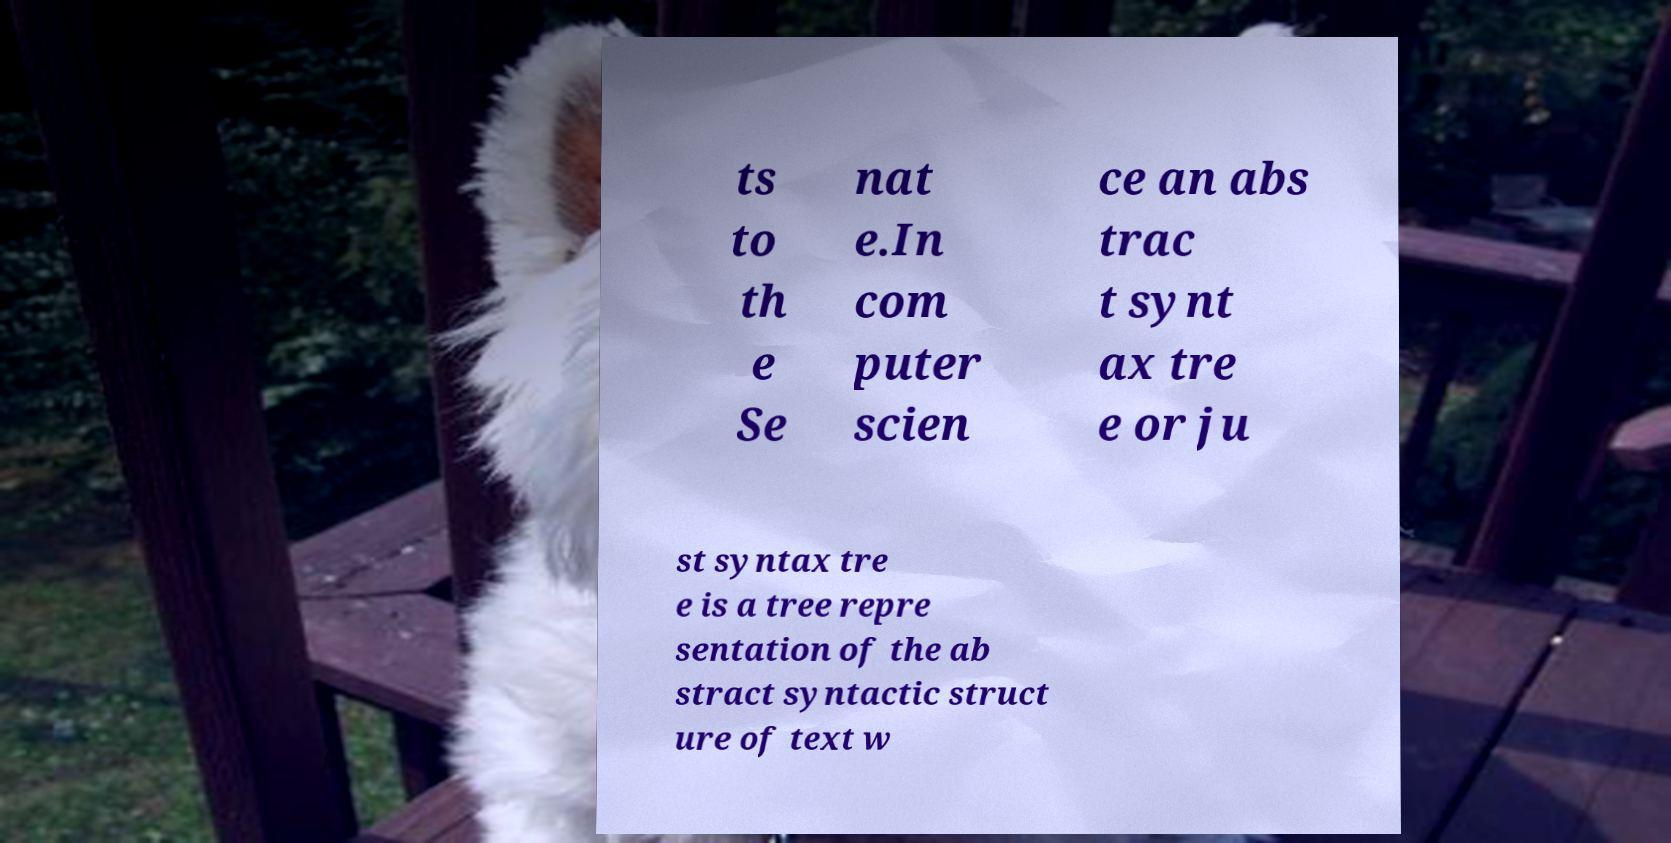Can you accurately transcribe the text from the provided image for me? ts to th e Se nat e.In com puter scien ce an abs trac t synt ax tre e or ju st syntax tre e is a tree repre sentation of the ab stract syntactic struct ure of text w 